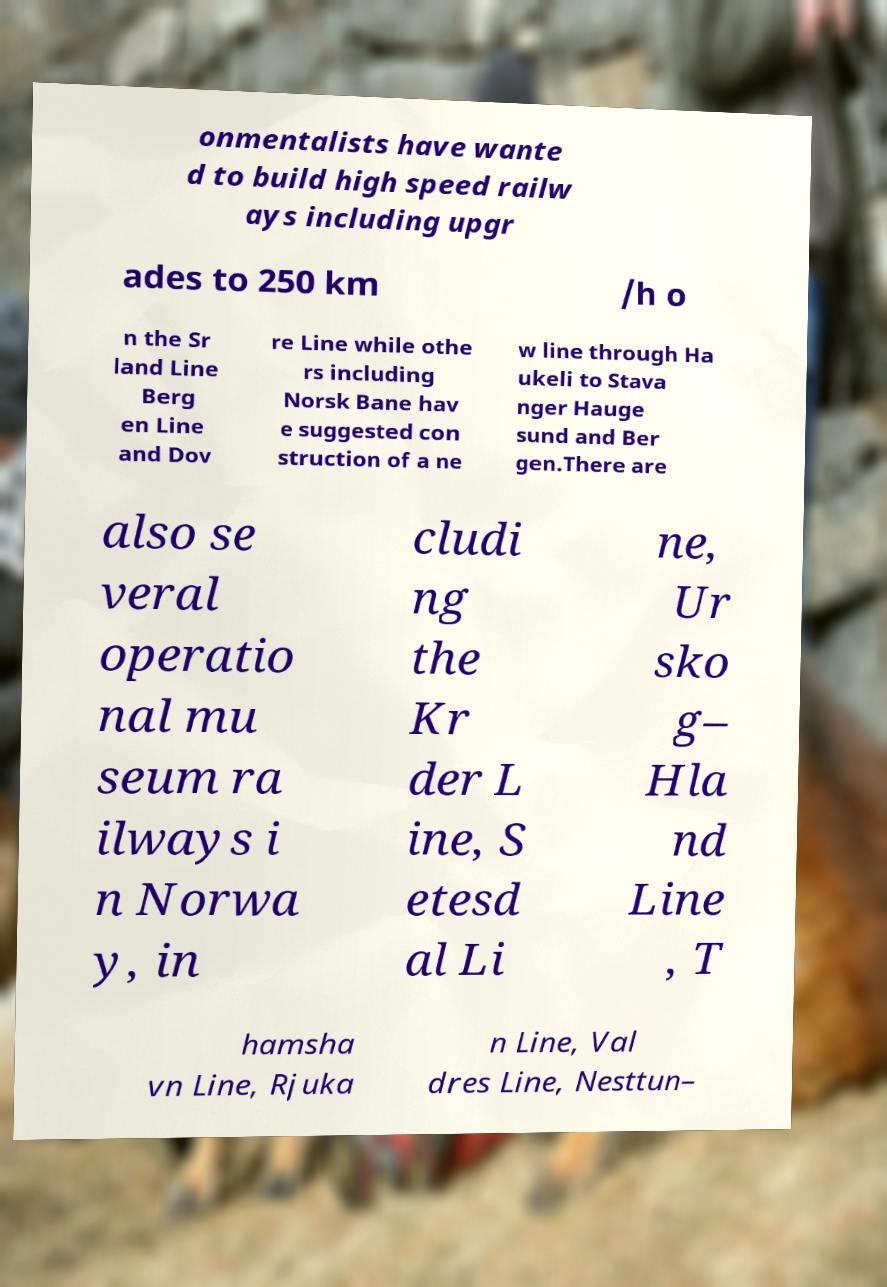Please read and relay the text visible in this image. What does it say? onmentalists have wante d to build high speed railw ays including upgr ades to 250 km /h o n the Sr land Line Berg en Line and Dov re Line while othe rs including Norsk Bane hav e suggested con struction of a ne w line through Ha ukeli to Stava nger Hauge sund and Ber gen.There are also se veral operatio nal mu seum ra ilways i n Norwa y, in cludi ng the Kr der L ine, S etesd al Li ne, Ur sko g– Hla nd Line , T hamsha vn Line, Rjuka n Line, Val dres Line, Nesttun– 